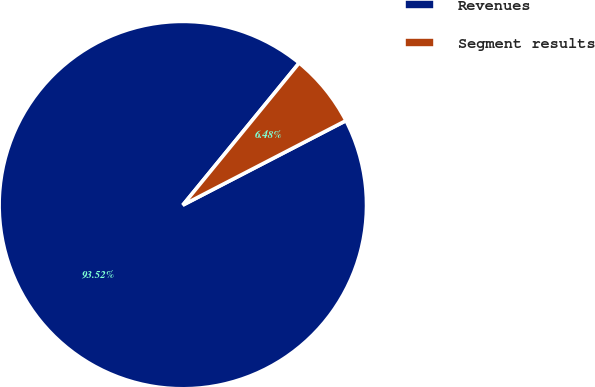Convert chart. <chart><loc_0><loc_0><loc_500><loc_500><pie_chart><fcel>Revenues<fcel>Segment results<nl><fcel>93.52%<fcel>6.48%<nl></chart> 